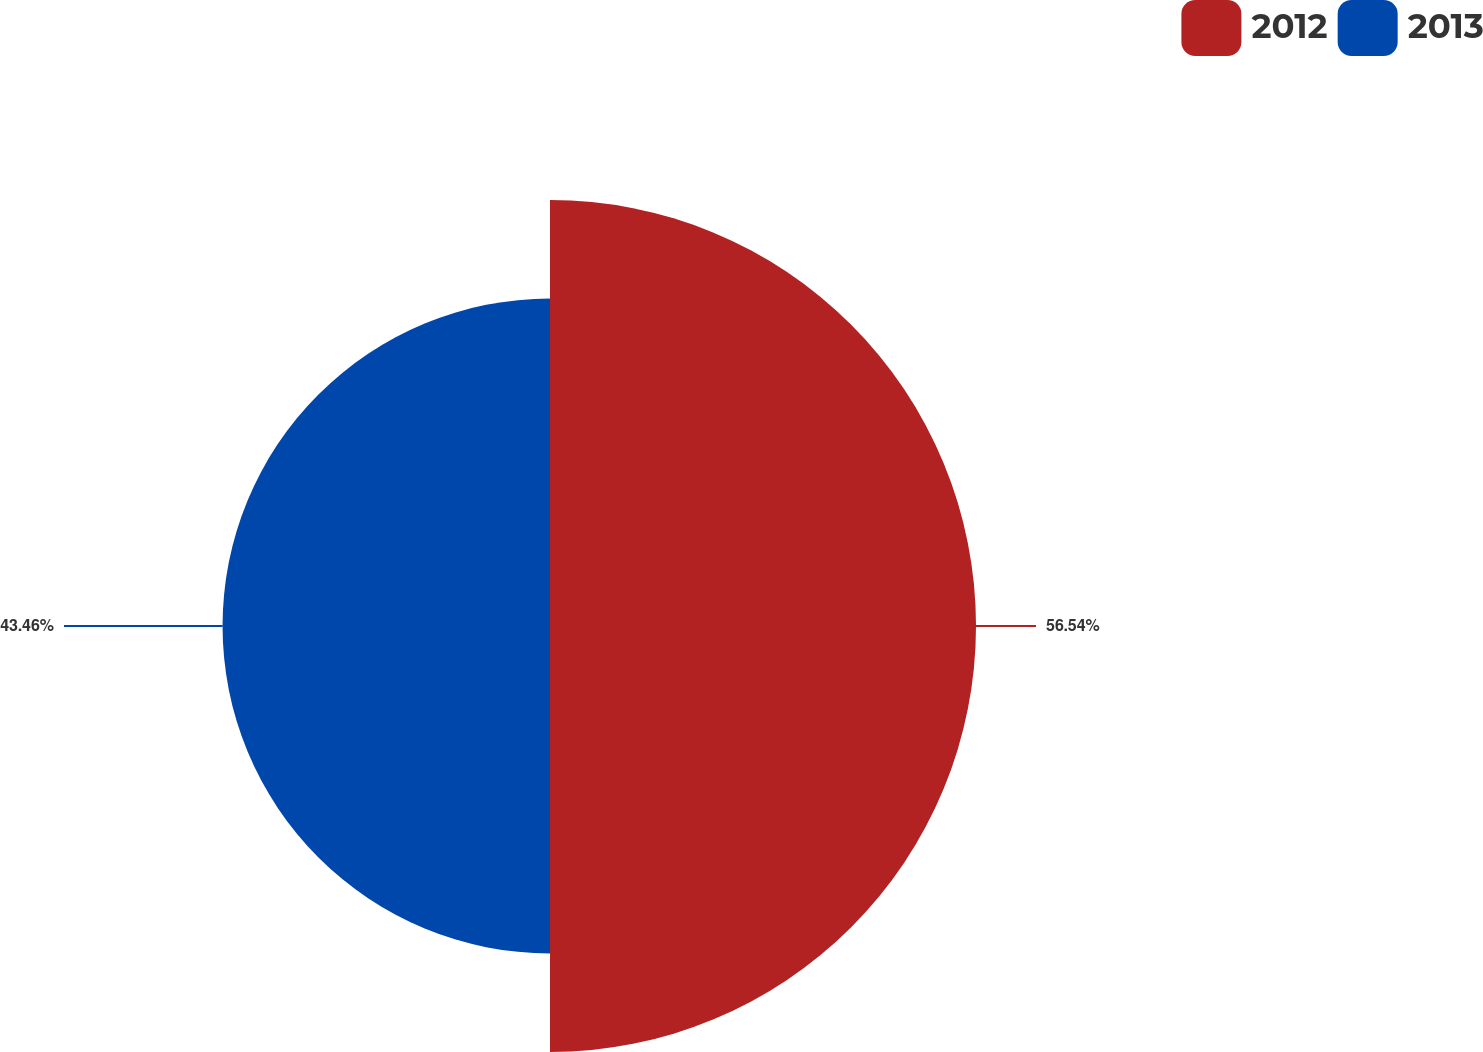<chart> <loc_0><loc_0><loc_500><loc_500><pie_chart><fcel>2012<fcel>2013<nl><fcel>56.54%<fcel>43.46%<nl></chart> 